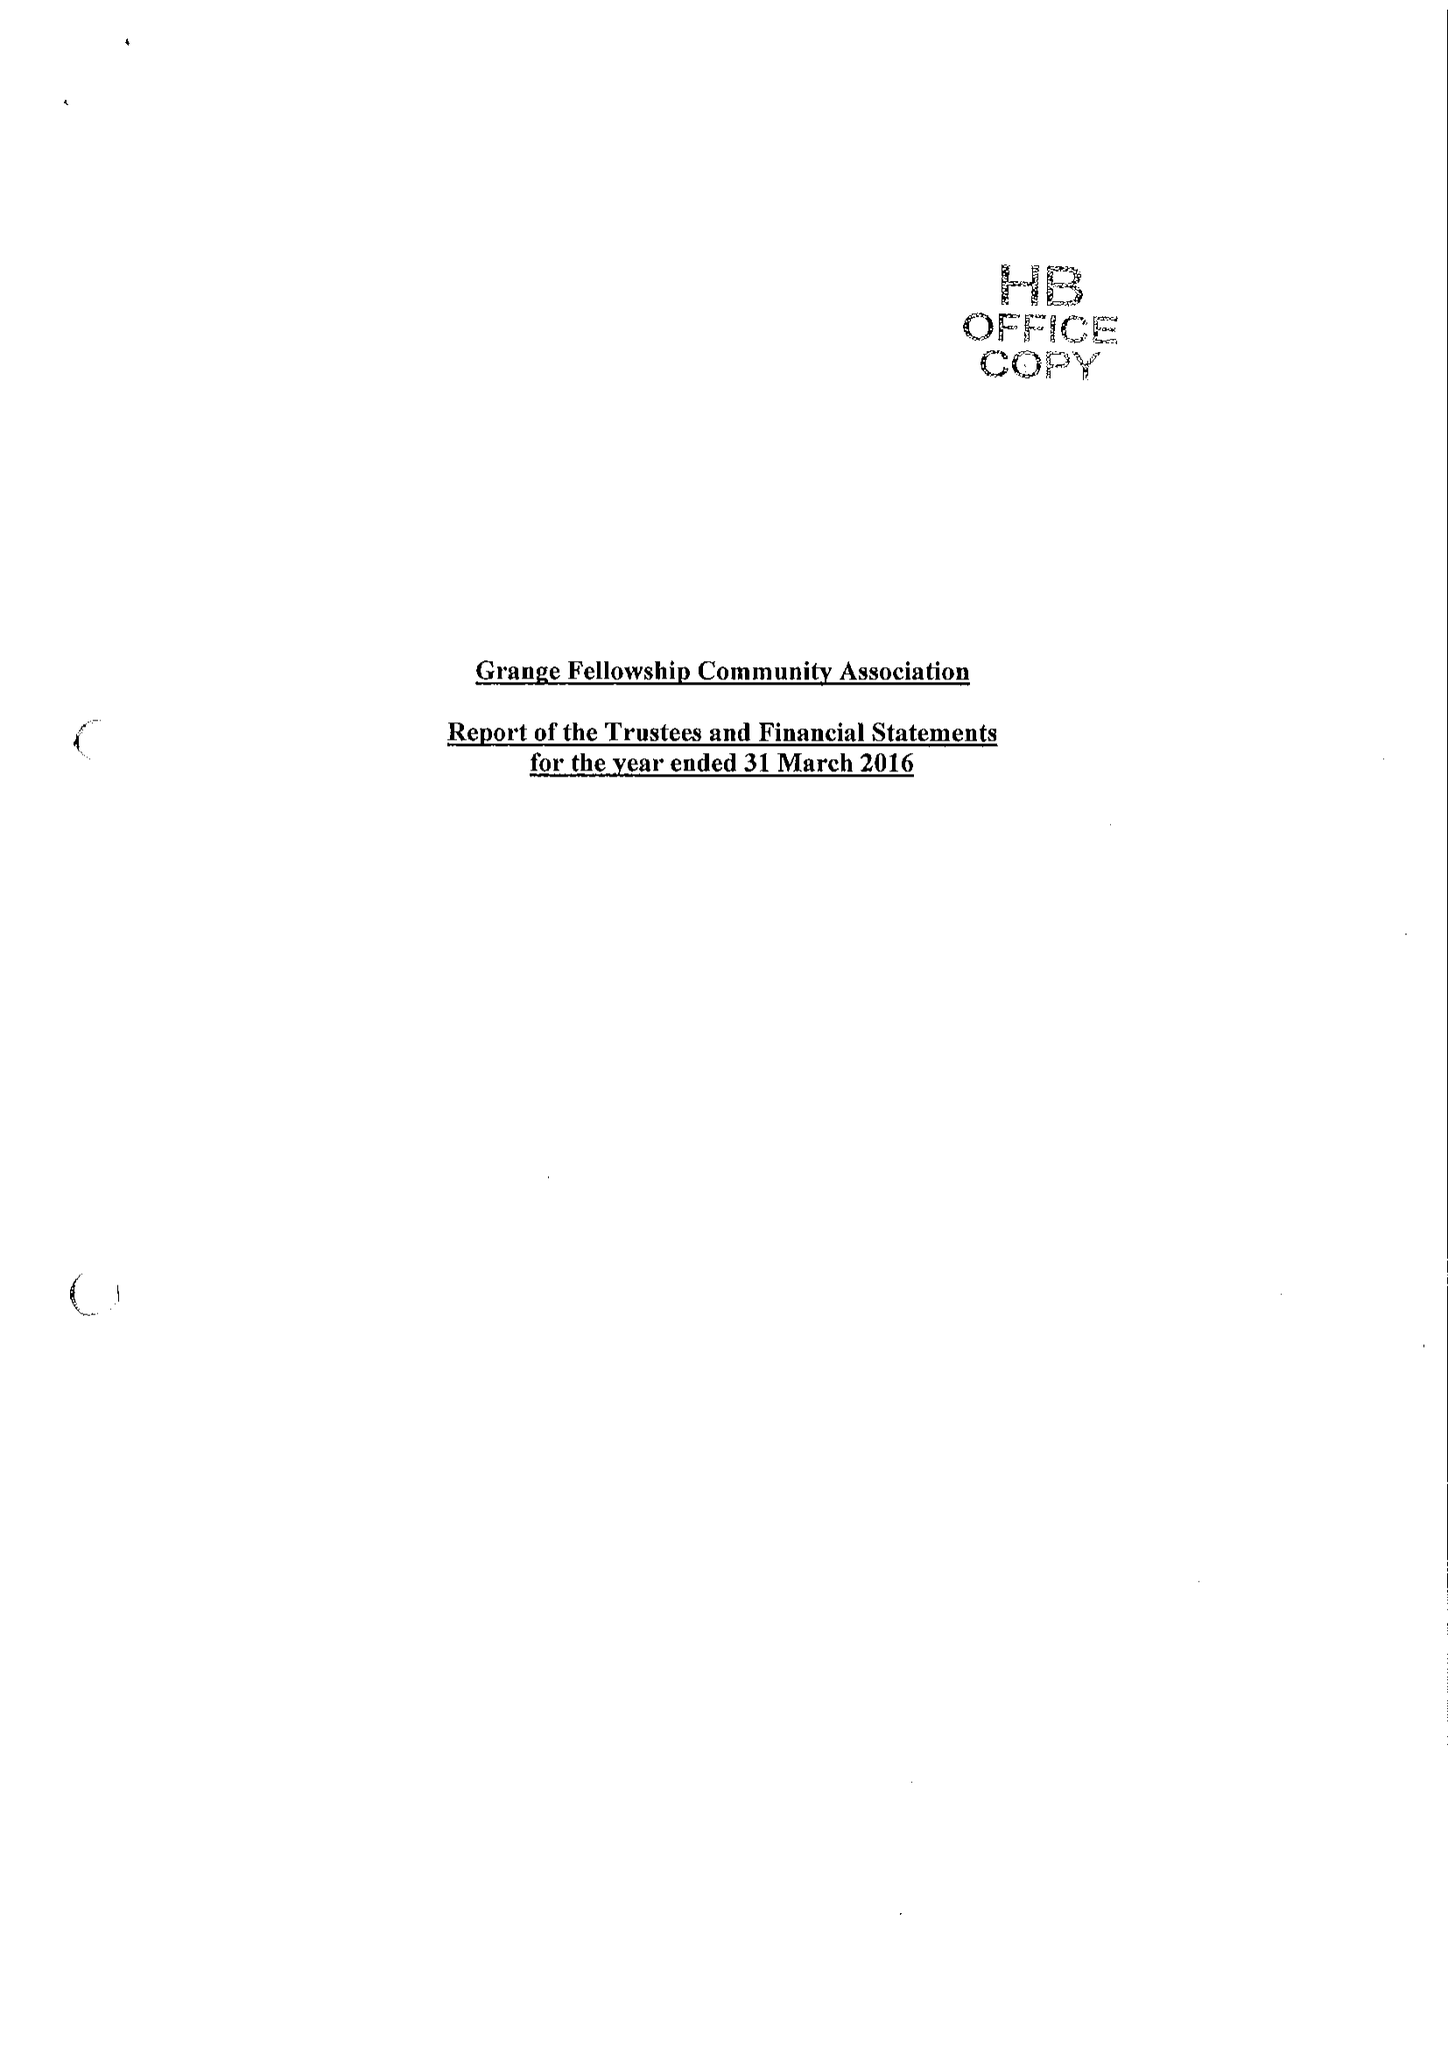What is the value for the charity_number?
Answer the question using a single word or phrase. 302420 